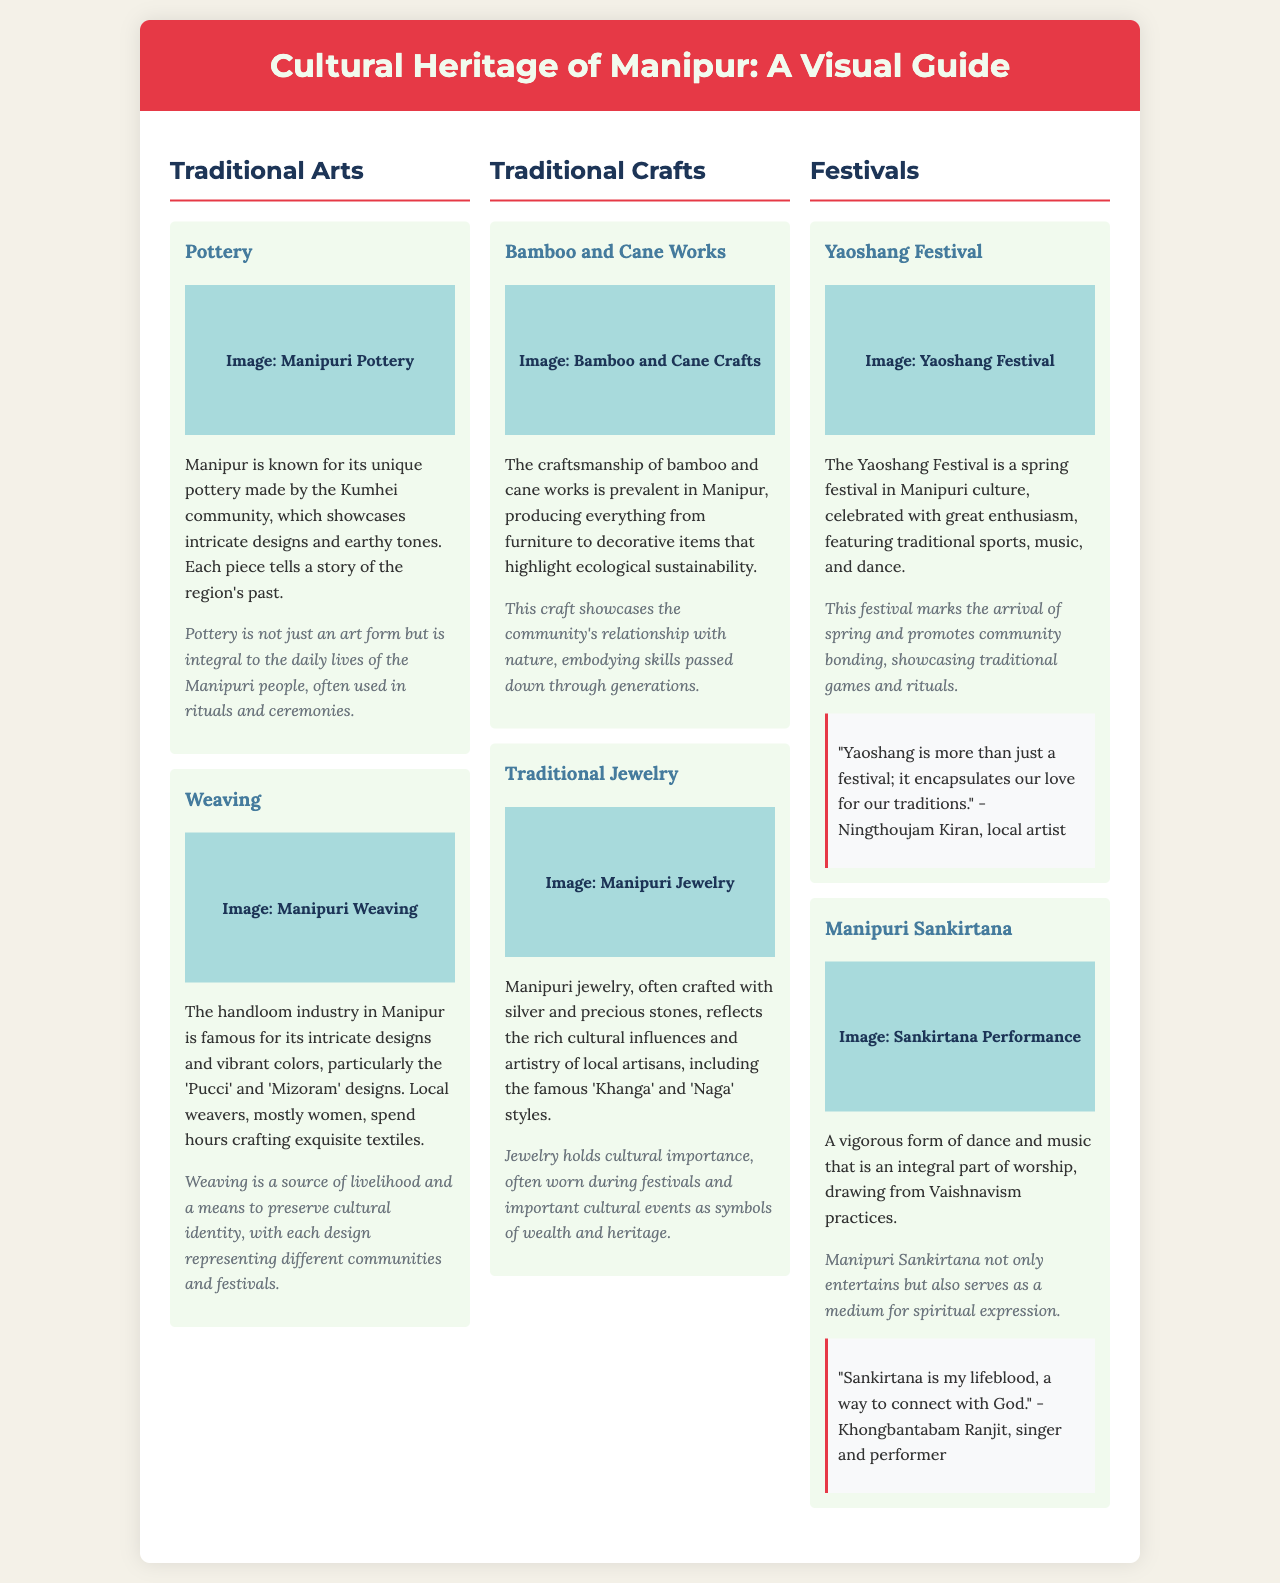What is the title of the brochure? The title of the brochure is prominently displayed at the top of the document.
Answer: Cultural Heritage of Manipur: A Visual Guide How many traditional arts are mentioned? The document lists two traditional arts, pottery and weaving, under the “Traditional Arts” section.
Answer: 2 Which community is known for pottery in Manipur? The document specifies the Kumhei community as the makers of traditional pottery in Manipur.
Answer: Kumhei What are the names of two weaving designs mentioned? The document mentions 'Pucci' and 'Mizoram' designs specifically regarding Manipuri weaving.
Answer: Pucci, Mizoram What festival is celebrated in spring? The brochure highlights the Yaoshang Festival as a significant spring festival in Manipuri culture.
Answer: Yaoshang Festival What is the cultural significance of traditional jewelry? The document states that jewelry is worn during festivals and important cultural events as symbols of wealth and heritage.
Answer: Symbols of wealth and heritage Who is quoted regarding the importance of Yaoshang? The document includes a quote from Ningthoujam Kiran about the significance of the Yaoshang festival.
Answer: Ningthoujam Kiran What medium does Manipuri Sankirtana serve for? The document indicates that Manipuri Sankirtana serves as a medium for spiritual expression.
Answer: Spiritual expression What material is prominently used in bamboo and cane crafts? The document emphasizes that bamboo and cane are the primary materials used in these traditional crafts.
Answer: Bamboo, Cane 